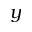<formula> <loc_0><loc_0><loc_500><loc_500>y</formula> 